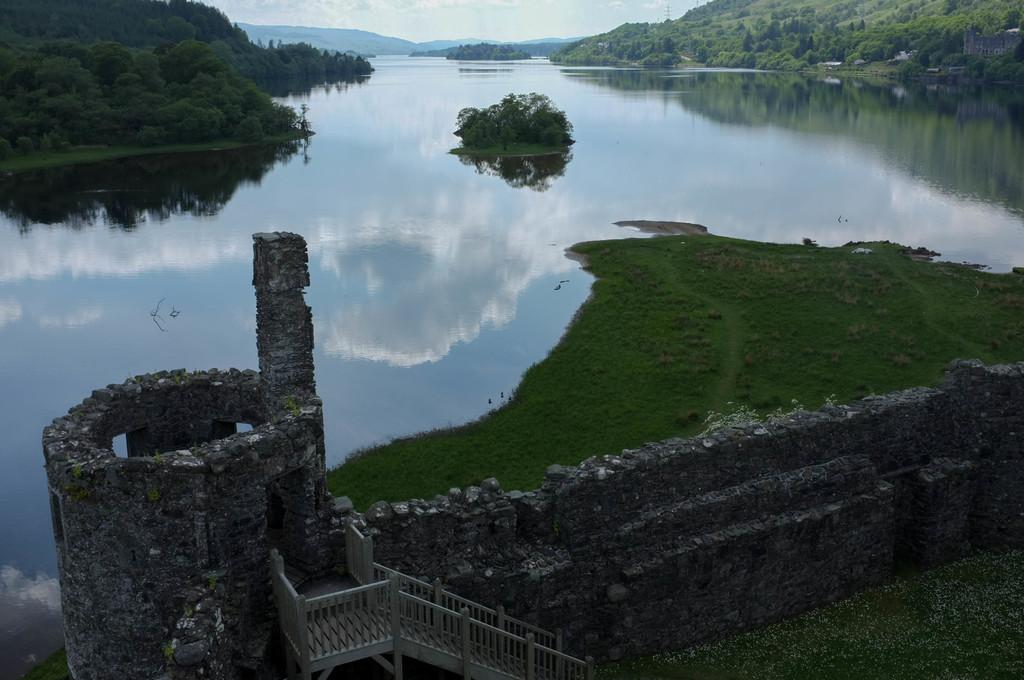What type of structure can be seen in the image? There are stairs in the image. What natural element is visible in the image? Water is visible in the image. What type of vegetation can be seen in the image? Plants, grass, and trees are present in the image. What geographical feature can be seen in the image? There are hills in the image. What is visible in the background of the image? The sky is visible in the background of the image. What type of silk is being used to make the popcorn in the image? There is no popcorn or silk present in the image. What type of fiction is being read by the trees in the image? There are no trees reading fiction in the image; the trees are simply part of the natural landscape. 